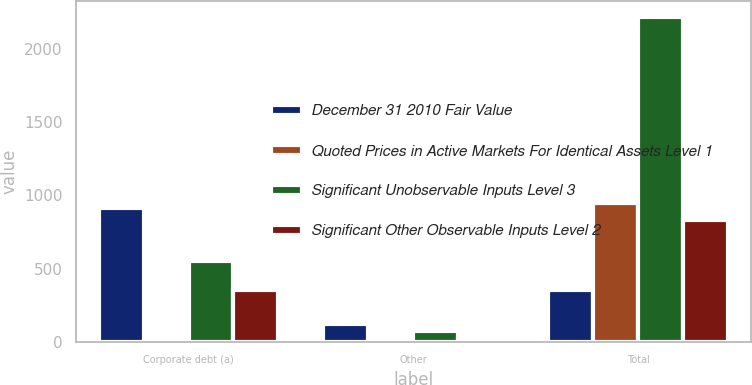Convert chart. <chart><loc_0><loc_0><loc_500><loc_500><stacked_bar_chart><ecel><fcel>Corporate debt (a)<fcel>Other<fcel>Total<nl><fcel>December 31 2010 Fair Value<fcel>916<fcel>122<fcel>353<nl><fcel>Quoted Prices in Active Markets For Identical Assets Level 1<fcel>8<fcel>14<fcel>946<nl><fcel>Significant Unobservable Inputs Level 3<fcel>555<fcel>77<fcel>2216<nl><fcel>Significant Other Observable Inputs Level 2<fcel>353<fcel>31<fcel>829<nl></chart> 